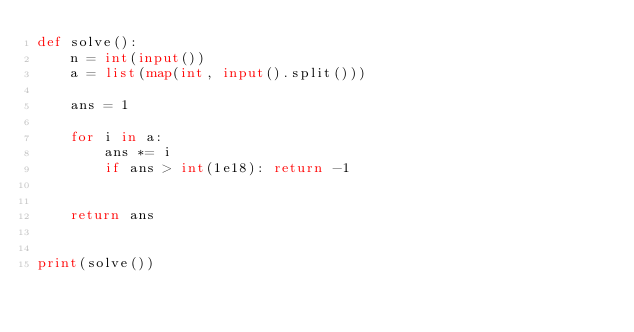Convert code to text. <code><loc_0><loc_0><loc_500><loc_500><_Python_>def solve():
    n = int(input())
    a = list(map(int, input().split()))

    ans = 1
 
    for i in a:
        ans *= i
      	if ans > int(1e18): return -1
    
    
    return ans
    

print(solve())
</code> 